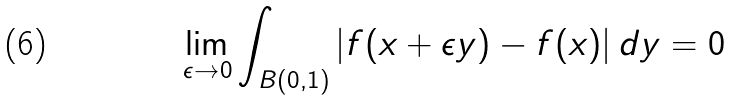<formula> <loc_0><loc_0><loc_500><loc_500>\lim _ { \epsilon \to 0 } \int _ { B ( 0 , 1 ) } | f ( x + \epsilon y ) - f ( x ) | \, d y = 0</formula> 